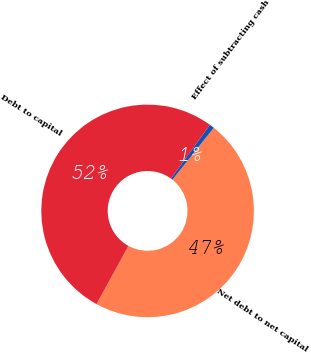<chart> <loc_0><loc_0><loc_500><loc_500><pie_chart><fcel>Net debt to net capital<fcel>Effect of subtracting cash<fcel>Debt to capital<nl><fcel>47.27%<fcel>0.73%<fcel>52.0%<nl></chart> 